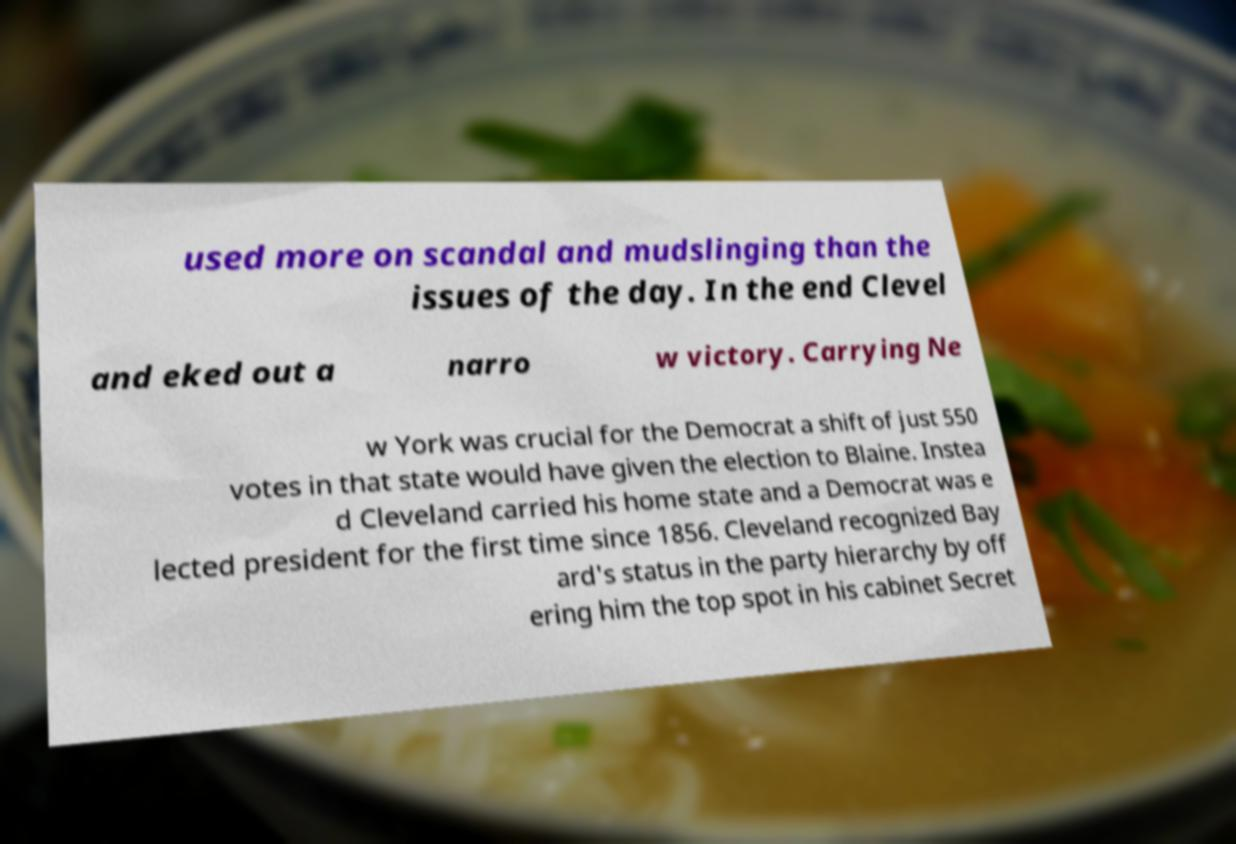Can you read and provide the text displayed in the image?This photo seems to have some interesting text. Can you extract and type it out for me? used more on scandal and mudslinging than the issues of the day. In the end Clevel and eked out a narro w victory. Carrying Ne w York was crucial for the Democrat a shift of just 550 votes in that state would have given the election to Blaine. Instea d Cleveland carried his home state and a Democrat was e lected president for the first time since 1856. Cleveland recognized Bay ard's status in the party hierarchy by off ering him the top spot in his cabinet Secret 